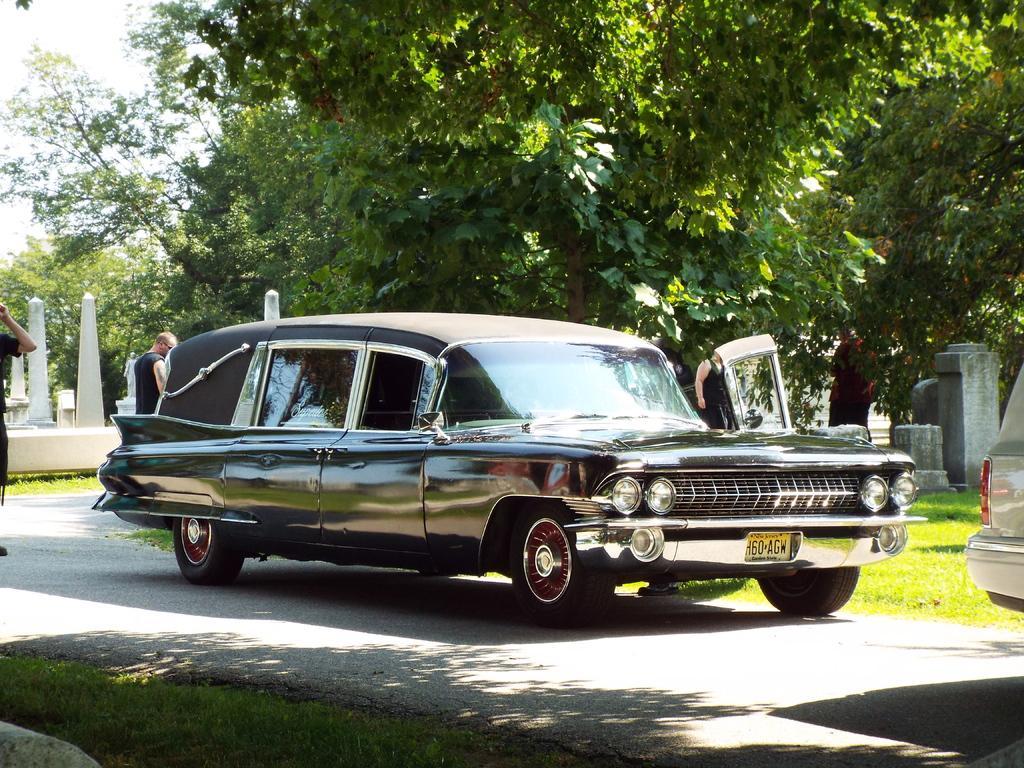Can you describe this image briefly? In the picture we can see a road on it, we can see a vintage car and near it, we can see some persons are standing near it and inside the car we can see a grass surface and tree on it and behind the car we can see some poles and in the background we can see trees and sky. 